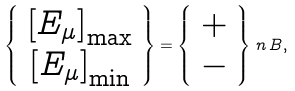<formula> <loc_0><loc_0><loc_500><loc_500>\left \{ \begin{array} { c } \left [ E _ { \mu } \right ] _ { \max } \\ \left [ E _ { \mu } \right ] _ { \min } \end{array} \right \} = \left \{ \begin{array} { c } + \\ - \end{array} \right \} \, n \, B ,</formula> 